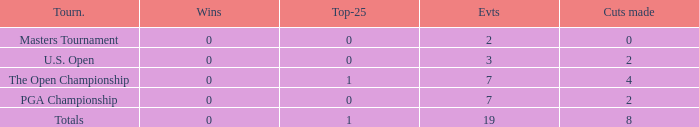What is the lowest Top-25 with Wins less than 0? None. 